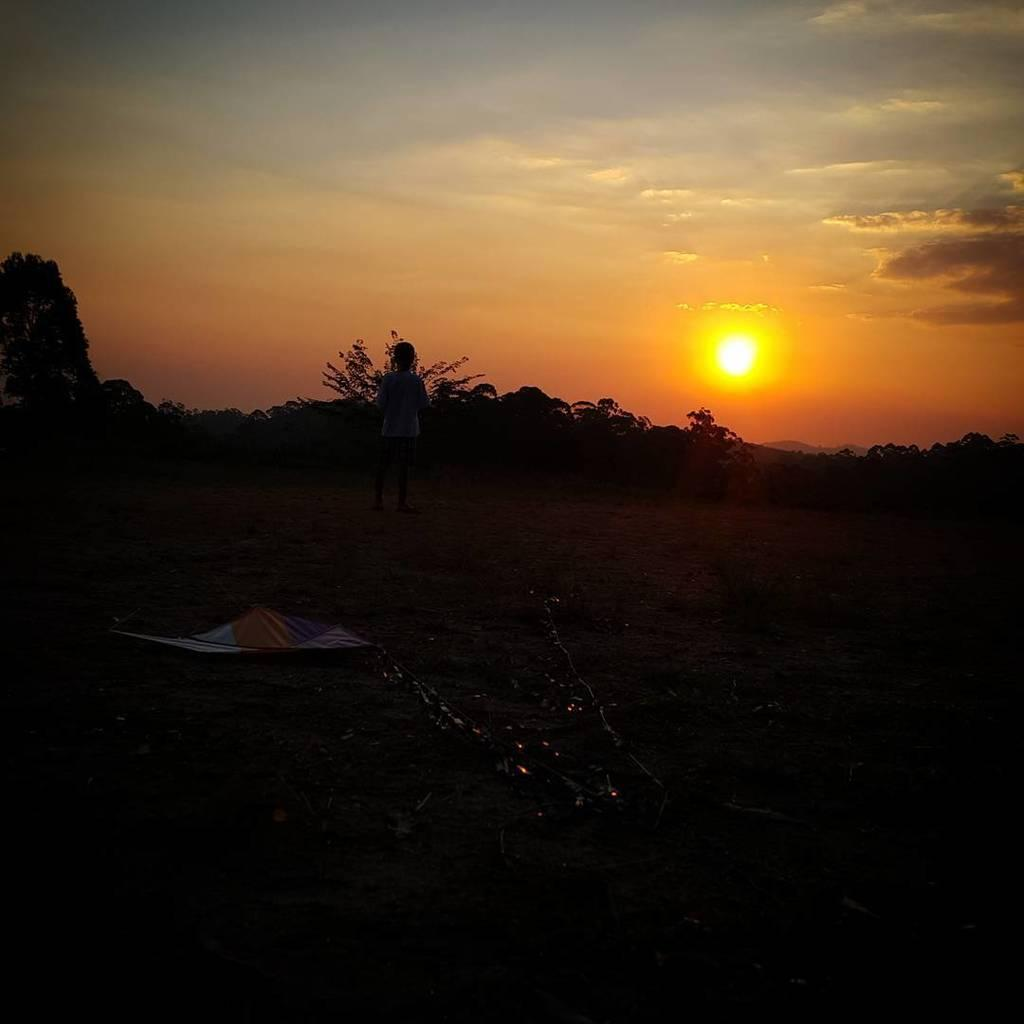What is the main subject of the image? There is a person standing on the ground in the image. What can be seen in the background of the image? Trees are visible in the image. What is the condition of the sky in the image? The sun and clouds are visible in the sky. What type of health advice can be seen on the trees in the image? There is no health advice present on the trees in the image; they are simply trees in the background. 